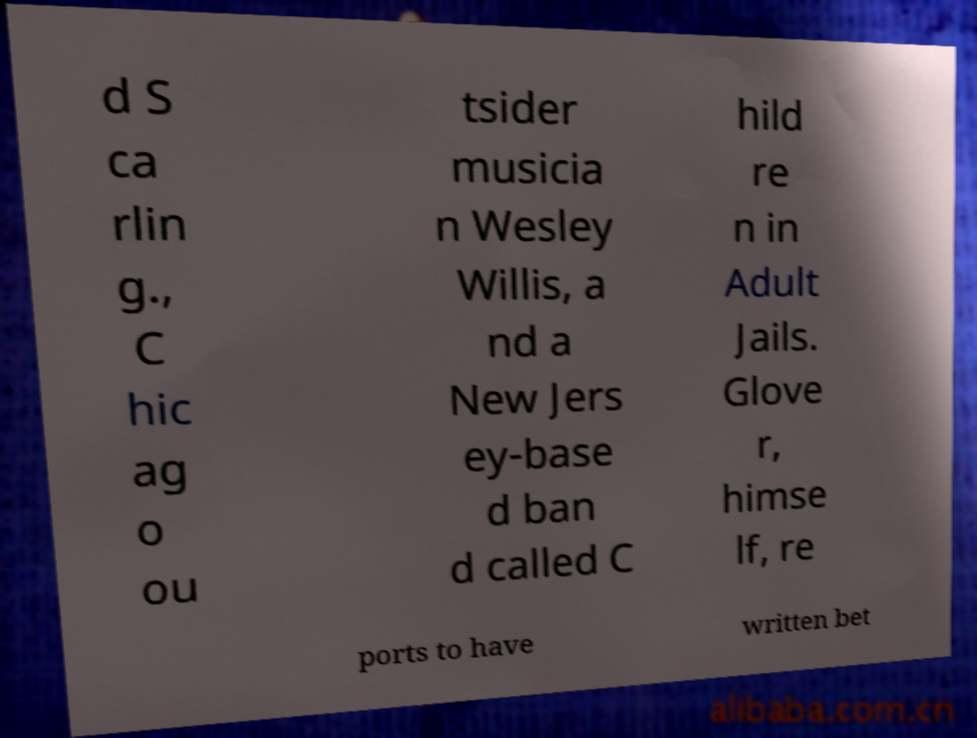Please identify and transcribe the text found in this image. d S ca rlin g., C hic ag o ou tsider musicia n Wesley Willis, a nd a New Jers ey-base d ban d called C hild re n in Adult Jails. Glove r, himse lf, re ports to have written bet 